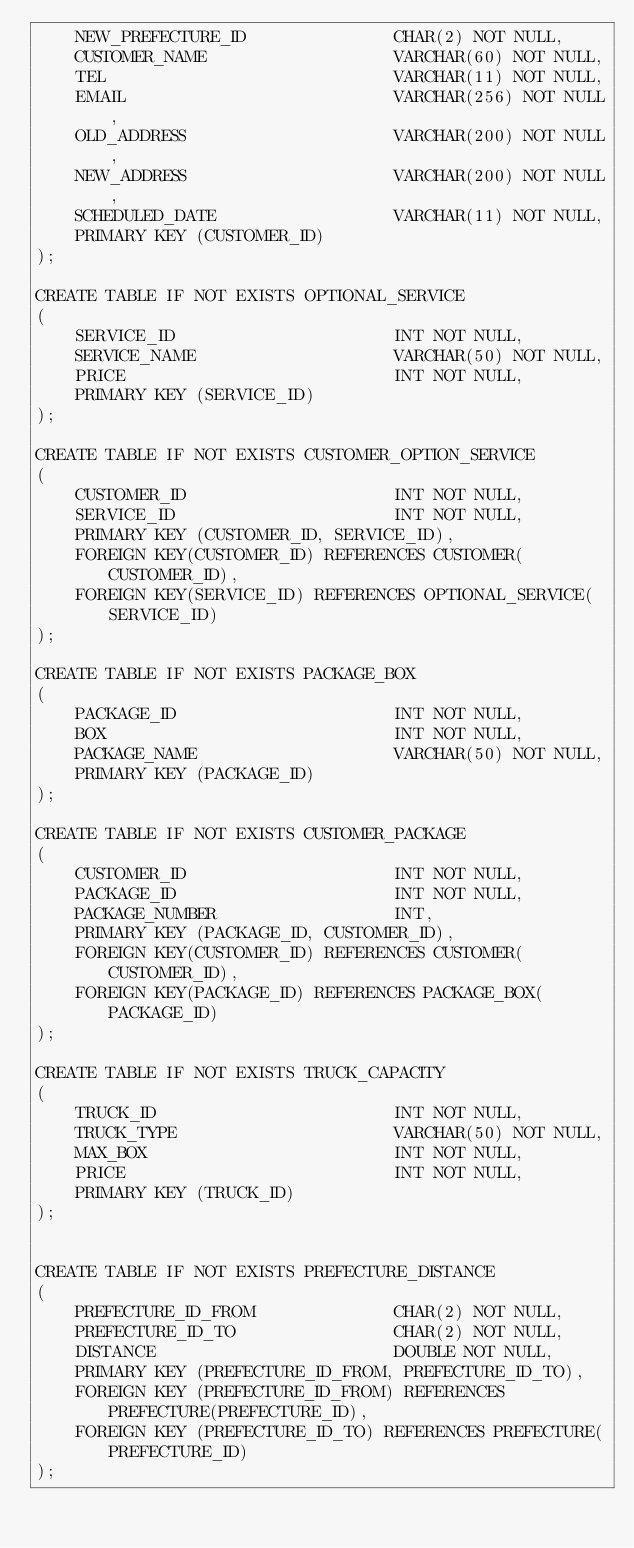<code> <loc_0><loc_0><loc_500><loc_500><_SQL_>    NEW_PREFECTURE_ID               CHAR(2) NOT NULL,
    CUSTOMER_NAME                   VARCHAR(60) NOT NULL,
    TEL                             VARCHAR(11) NOT NULL,
    EMAIL                           VARCHAR(256) NOT NULL,
    OLD_ADDRESS                     VARCHAR(200) NOT NULL,
    NEW_ADDRESS                     VARCHAR(200) NOT NULL,
    SCHEDULED_DATE                  VARCHAR(11) NOT NULL,
    PRIMARY KEY (CUSTOMER_ID)
);

CREATE TABLE IF NOT EXISTS OPTIONAL_SERVICE
(
    SERVICE_ID                      INT NOT NULL,
    SERVICE_NAME                    VARCHAR(50) NOT NULL,
    PRICE                           INT NOT NULL,
    PRIMARY KEY (SERVICE_ID)
);

CREATE TABLE IF NOT EXISTS CUSTOMER_OPTION_SERVICE
(
    CUSTOMER_ID                     INT NOT NULL,
    SERVICE_ID                      INT NOT NULL,
    PRIMARY KEY (CUSTOMER_ID, SERVICE_ID),
    FOREIGN KEY(CUSTOMER_ID) REFERENCES CUSTOMER(CUSTOMER_ID),
    FOREIGN KEY(SERVICE_ID) REFERENCES OPTIONAL_SERVICE(SERVICE_ID)
);

CREATE TABLE IF NOT EXISTS PACKAGE_BOX
(
    PACKAGE_ID                      INT NOT NULL,
    BOX                             INT NOT NULL,
    PACKAGE_NAME                    VARCHAR(50) NOT NULL,
    PRIMARY KEY (PACKAGE_ID)
);

CREATE TABLE IF NOT EXISTS CUSTOMER_PACKAGE
(
    CUSTOMER_ID                     INT NOT NULL,
    PACKAGE_ID                      INT NOT NULL,
    PACKAGE_NUMBER                  INT,
    PRIMARY KEY (PACKAGE_ID, CUSTOMER_ID),
    FOREIGN KEY(CUSTOMER_ID) REFERENCES CUSTOMER(CUSTOMER_ID),
    FOREIGN KEY(PACKAGE_ID) REFERENCES PACKAGE_BOX(PACKAGE_ID)
);

CREATE TABLE IF NOT EXISTS TRUCK_CAPACITY
(
    TRUCK_ID                        INT NOT NULL,
    TRUCK_TYPE                      VARCHAR(50) NOT NULL,
    MAX_BOX                         INT NOT NULL,
    PRICE                           INT NOT NULL,
    PRIMARY KEY (TRUCK_ID)
);


CREATE TABLE IF NOT EXISTS PREFECTURE_DISTANCE
(
    PREFECTURE_ID_FROM              CHAR(2) NOT NULL,
    PREFECTURE_ID_TO                CHAR(2) NOT NULL,
    DISTANCE                        DOUBLE NOT NULL,
    PRIMARY KEY (PREFECTURE_ID_FROM, PREFECTURE_ID_TO),
    FOREIGN KEY (PREFECTURE_ID_FROM) REFERENCES PREFECTURE(PREFECTURE_ID),
    FOREIGN KEY (PREFECTURE_ID_TO) REFERENCES PREFECTURE(PREFECTURE_ID)
);


</code> 